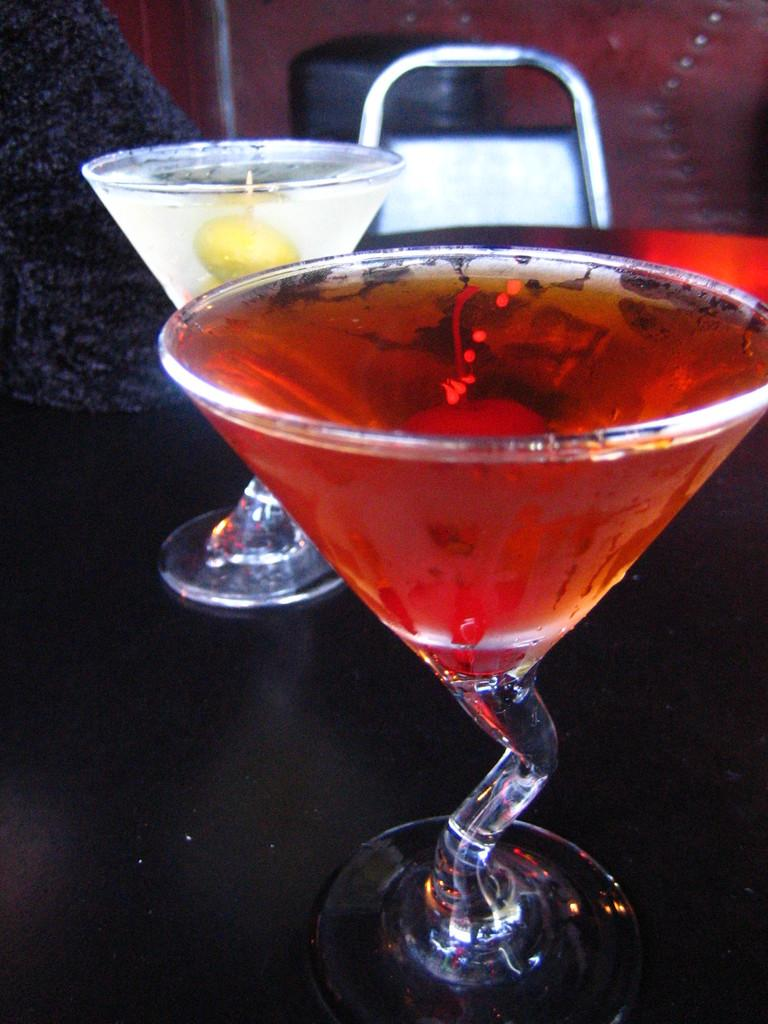What type of beverages are present in the image? There are cocktails in the image. Where are the cocktails located? The cocktails are placed on a table. Can you describe any furniture visible in the image? There is a chair visible in the background of the image. What type of brush is being used to mix the cocktails in the image? There is no brush present in the image, and cocktails are not typically mixed with a brush. 